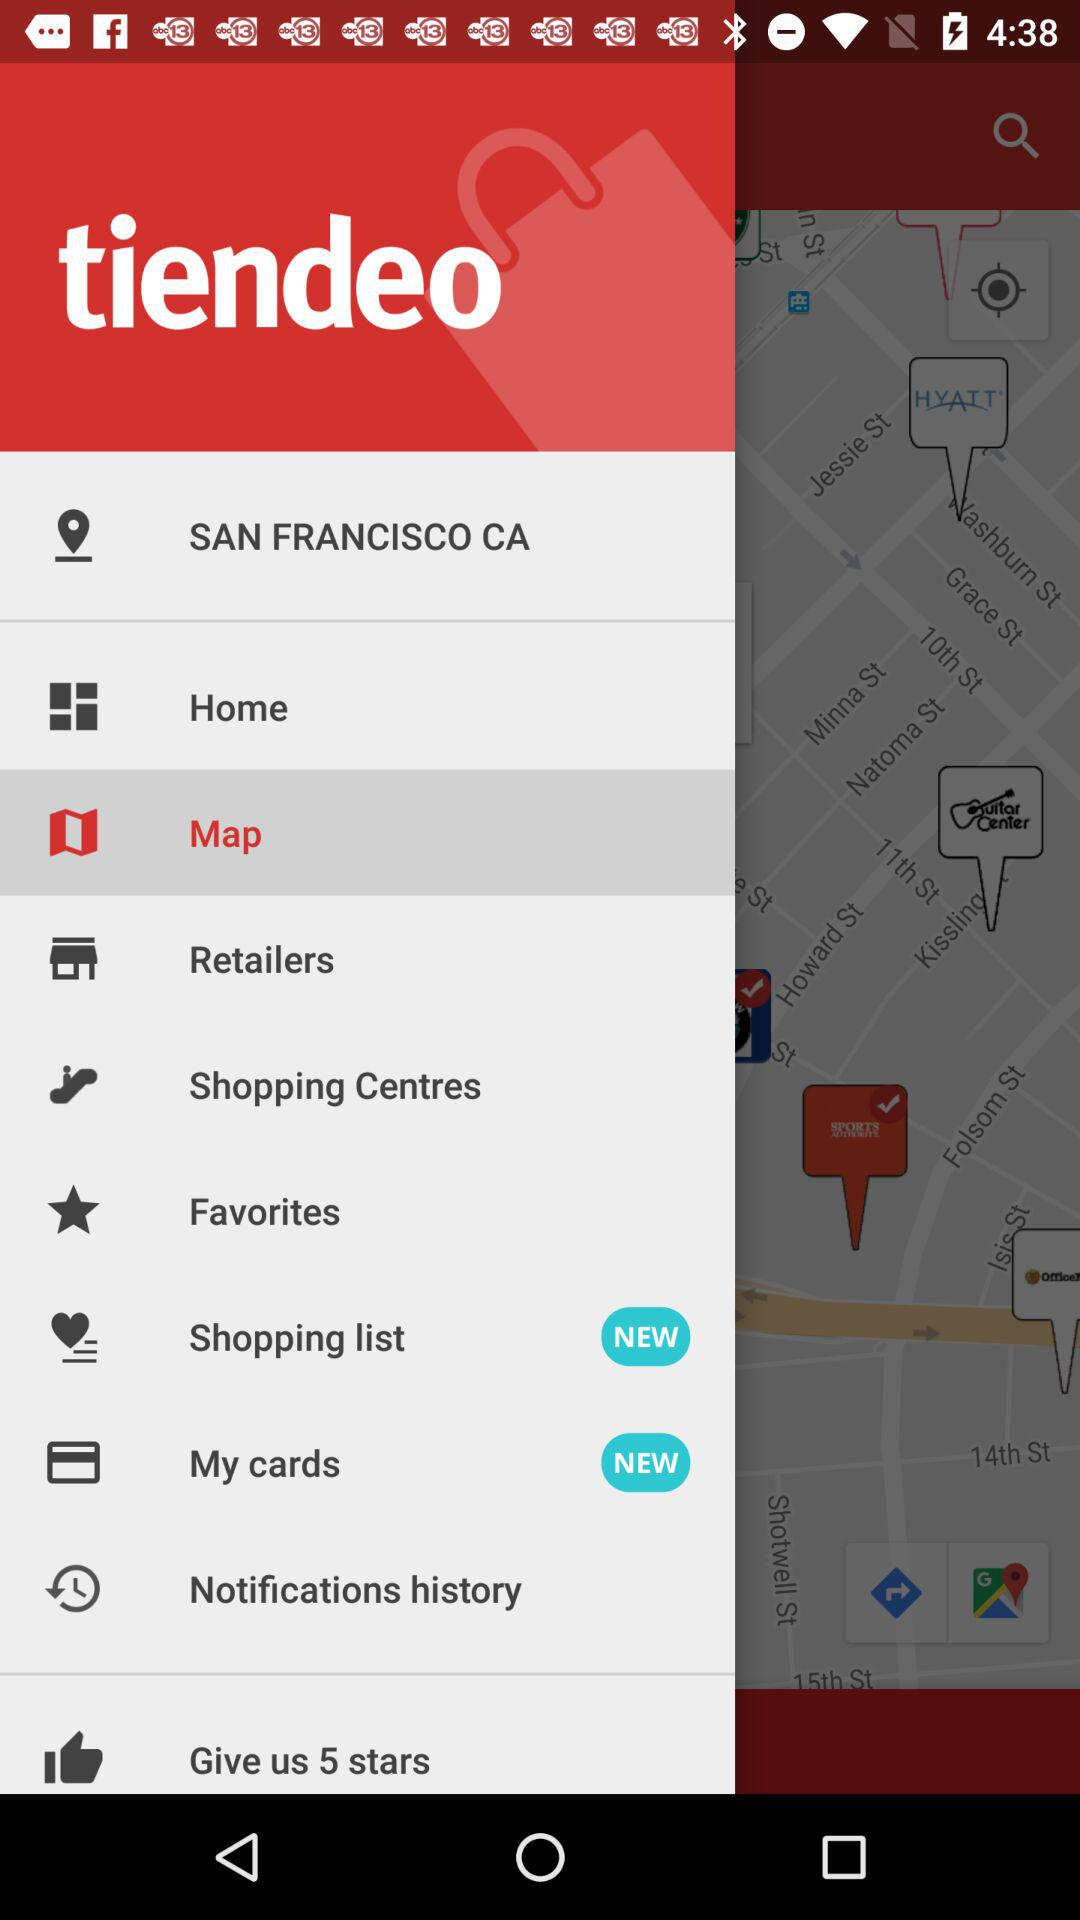Which item has been selected? The selected item is "Map". 